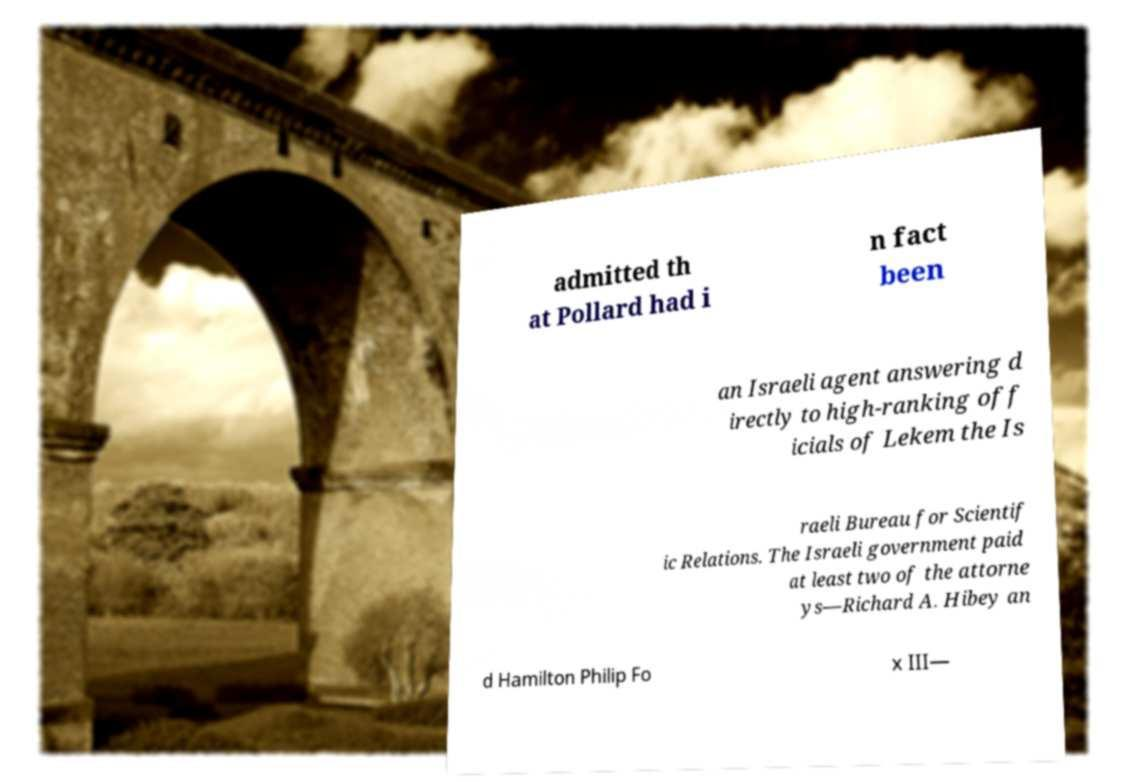What messages or text are displayed in this image? I need them in a readable, typed format. admitted th at Pollard had i n fact been an Israeli agent answering d irectly to high-ranking off icials of Lekem the Is raeli Bureau for Scientif ic Relations. The Israeli government paid at least two of the attorne ys—Richard A. Hibey an d Hamilton Philip Fo x III— 